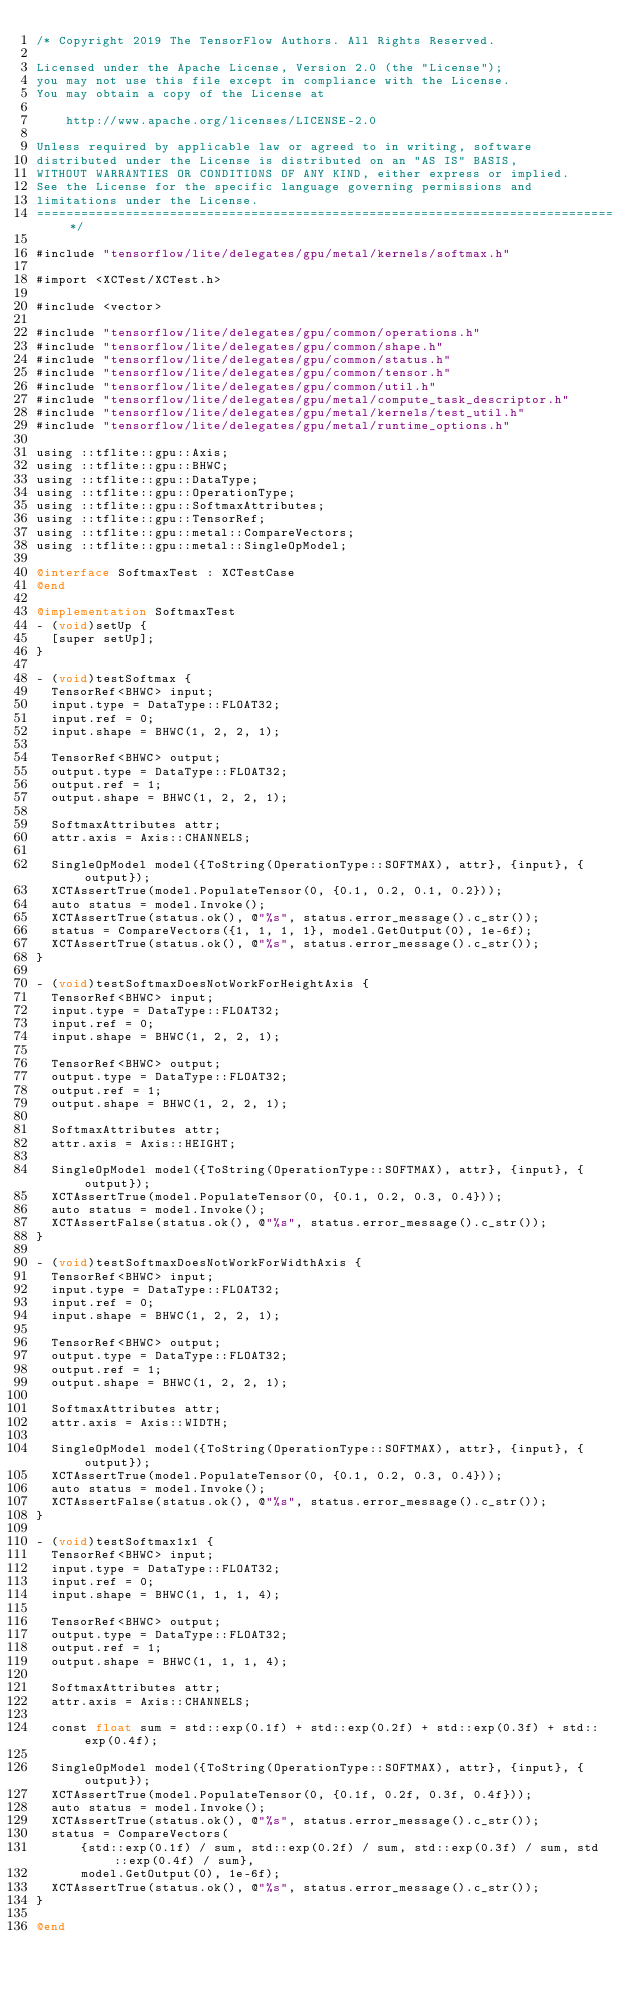Convert code to text. <code><loc_0><loc_0><loc_500><loc_500><_ObjectiveC_>/* Copyright 2019 The TensorFlow Authors. All Rights Reserved.

Licensed under the Apache License, Version 2.0 (the "License");
you may not use this file except in compliance with the License.
You may obtain a copy of the License at

    http://www.apache.org/licenses/LICENSE-2.0

Unless required by applicable law or agreed to in writing, software
distributed under the License is distributed on an "AS IS" BASIS,
WITHOUT WARRANTIES OR CONDITIONS OF ANY KIND, either express or implied.
See the License for the specific language governing permissions and
limitations under the License.
==============================================================================*/

#include "tensorflow/lite/delegates/gpu/metal/kernels/softmax.h"

#import <XCTest/XCTest.h>

#include <vector>

#include "tensorflow/lite/delegates/gpu/common/operations.h"
#include "tensorflow/lite/delegates/gpu/common/shape.h"
#include "tensorflow/lite/delegates/gpu/common/status.h"
#include "tensorflow/lite/delegates/gpu/common/tensor.h"
#include "tensorflow/lite/delegates/gpu/common/util.h"
#include "tensorflow/lite/delegates/gpu/metal/compute_task_descriptor.h"
#include "tensorflow/lite/delegates/gpu/metal/kernels/test_util.h"
#include "tensorflow/lite/delegates/gpu/metal/runtime_options.h"

using ::tflite::gpu::Axis;
using ::tflite::gpu::BHWC;
using ::tflite::gpu::DataType;
using ::tflite::gpu::OperationType;
using ::tflite::gpu::SoftmaxAttributes;
using ::tflite::gpu::TensorRef;
using ::tflite::gpu::metal::CompareVectors;
using ::tflite::gpu::metal::SingleOpModel;

@interface SoftmaxTest : XCTestCase
@end

@implementation SoftmaxTest
- (void)setUp {
  [super setUp];
}

- (void)testSoftmax {
  TensorRef<BHWC> input;
  input.type = DataType::FLOAT32;
  input.ref = 0;
  input.shape = BHWC(1, 2, 2, 1);

  TensorRef<BHWC> output;
  output.type = DataType::FLOAT32;
  output.ref = 1;
  output.shape = BHWC(1, 2, 2, 1);

  SoftmaxAttributes attr;
  attr.axis = Axis::CHANNELS;

  SingleOpModel model({ToString(OperationType::SOFTMAX), attr}, {input}, {output});
  XCTAssertTrue(model.PopulateTensor(0, {0.1, 0.2, 0.1, 0.2}));
  auto status = model.Invoke();
  XCTAssertTrue(status.ok(), @"%s", status.error_message().c_str());
  status = CompareVectors({1, 1, 1, 1}, model.GetOutput(0), 1e-6f);
  XCTAssertTrue(status.ok(), @"%s", status.error_message().c_str());
}

- (void)testSoftmaxDoesNotWorkForHeightAxis {
  TensorRef<BHWC> input;
  input.type = DataType::FLOAT32;
  input.ref = 0;
  input.shape = BHWC(1, 2, 2, 1);

  TensorRef<BHWC> output;
  output.type = DataType::FLOAT32;
  output.ref = 1;
  output.shape = BHWC(1, 2, 2, 1);

  SoftmaxAttributes attr;
  attr.axis = Axis::HEIGHT;

  SingleOpModel model({ToString(OperationType::SOFTMAX), attr}, {input}, {output});
  XCTAssertTrue(model.PopulateTensor(0, {0.1, 0.2, 0.3, 0.4}));
  auto status = model.Invoke();
  XCTAssertFalse(status.ok(), @"%s", status.error_message().c_str());
}

- (void)testSoftmaxDoesNotWorkForWidthAxis {
  TensorRef<BHWC> input;
  input.type = DataType::FLOAT32;
  input.ref = 0;
  input.shape = BHWC(1, 2, 2, 1);

  TensorRef<BHWC> output;
  output.type = DataType::FLOAT32;
  output.ref = 1;
  output.shape = BHWC(1, 2, 2, 1);

  SoftmaxAttributes attr;
  attr.axis = Axis::WIDTH;

  SingleOpModel model({ToString(OperationType::SOFTMAX), attr}, {input}, {output});
  XCTAssertTrue(model.PopulateTensor(0, {0.1, 0.2, 0.3, 0.4}));
  auto status = model.Invoke();
  XCTAssertFalse(status.ok(), @"%s", status.error_message().c_str());
}

- (void)testSoftmax1x1 {
  TensorRef<BHWC> input;
  input.type = DataType::FLOAT32;
  input.ref = 0;
  input.shape = BHWC(1, 1, 1, 4);

  TensorRef<BHWC> output;
  output.type = DataType::FLOAT32;
  output.ref = 1;
  output.shape = BHWC(1, 1, 1, 4);

  SoftmaxAttributes attr;
  attr.axis = Axis::CHANNELS;

  const float sum = std::exp(0.1f) + std::exp(0.2f) + std::exp(0.3f) + std::exp(0.4f);

  SingleOpModel model({ToString(OperationType::SOFTMAX), attr}, {input}, {output});
  XCTAssertTrue(model.PopulateTensor(0, {0.1f, 0.2f, 0.3f, 0.4f}));
  auto status = model.Invoke();
  XCTAssertTrue(status.ok(), @"%s", status.error_message().c_str());
  status = CompareVectors(
      {std::exp(0.1f) / sum, std::exp(0.2f) / sum, std::exp(0.3f) / sum, std::exp(0.4f) / sum},
      model.GetOutput(0), 1e-6f);
  XCTAssertTrue(status.ok(), @"%s", status.error_message().c_str());
}

@end
</code> 